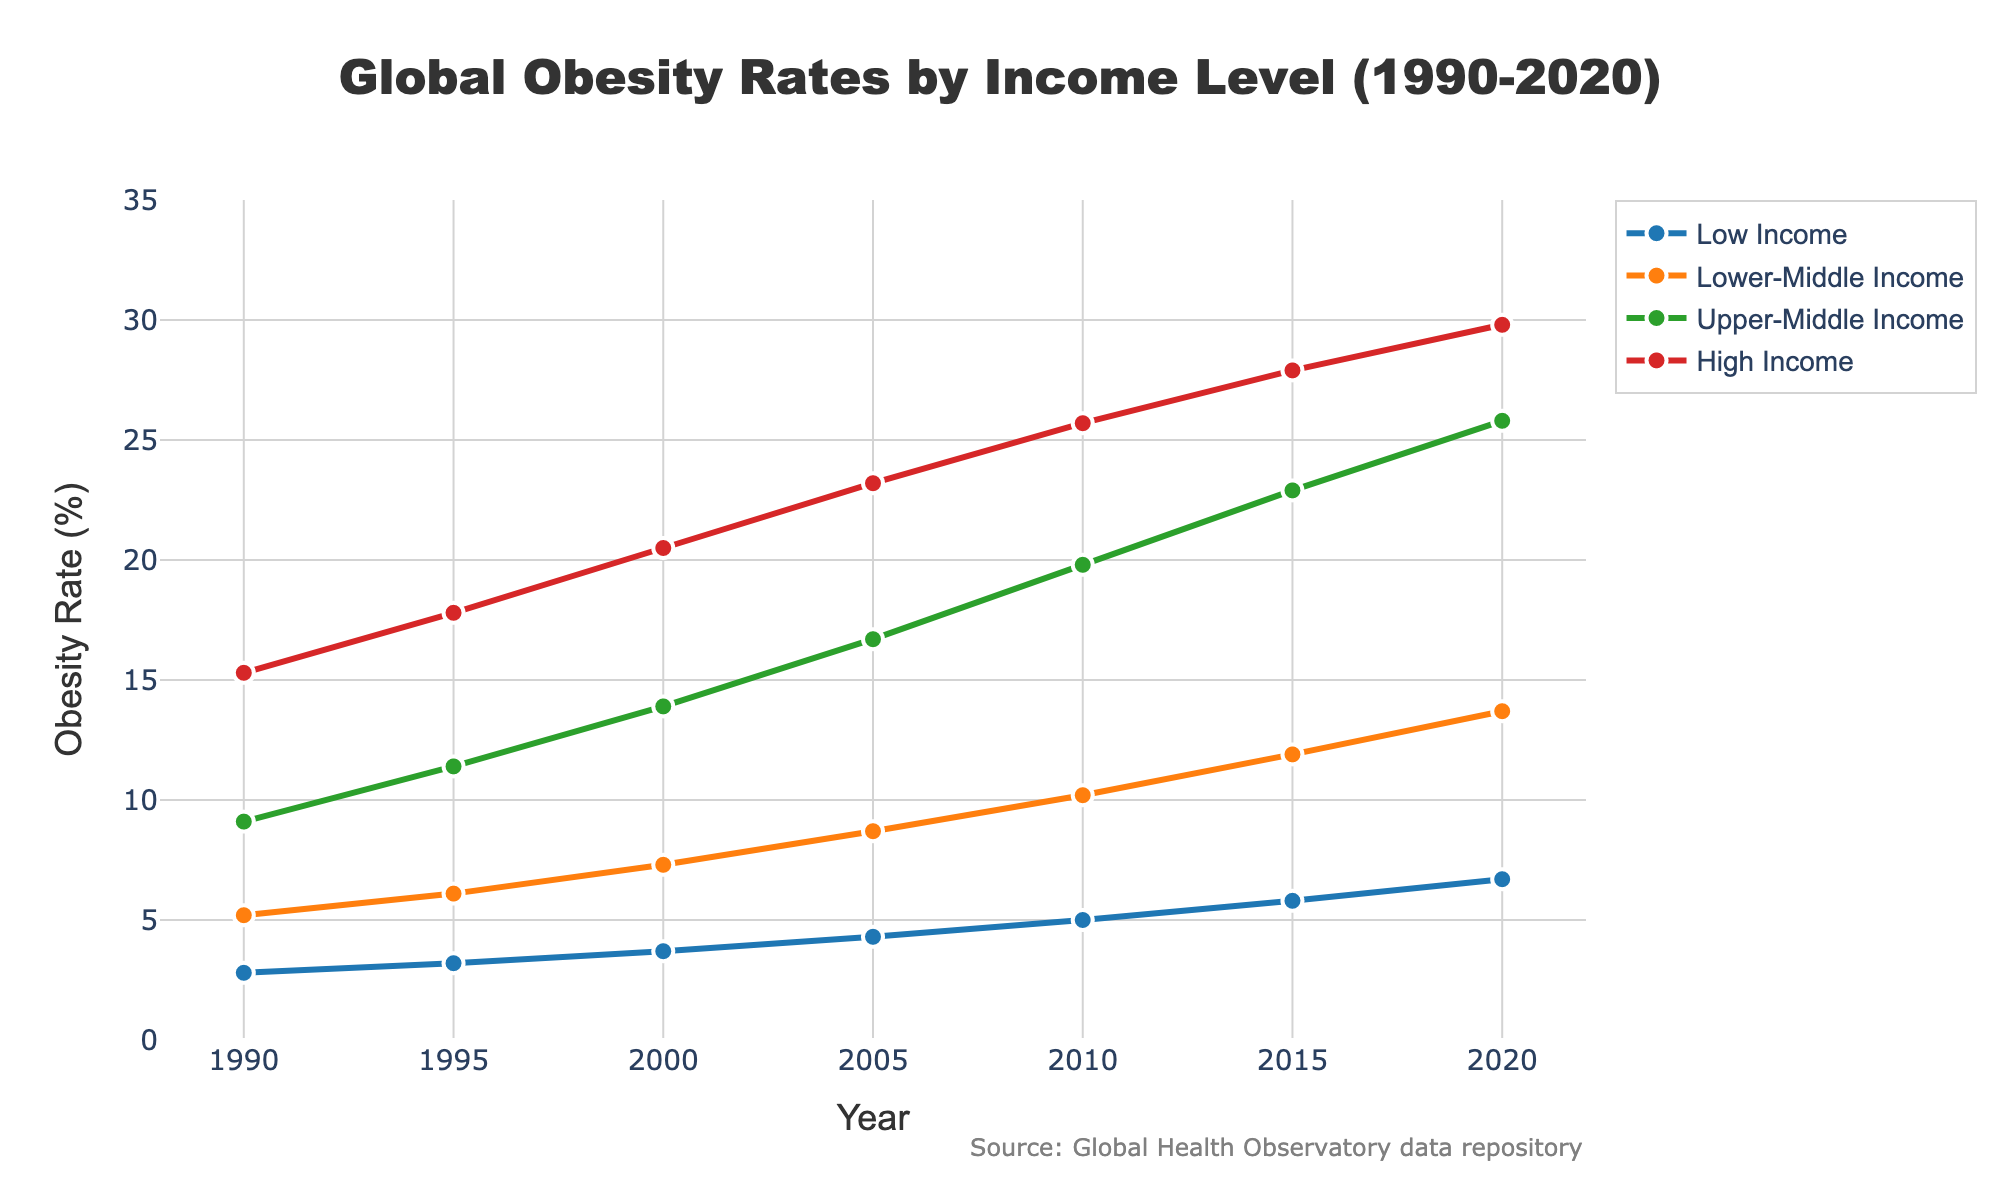What is the obesity rate for High Income countries in 2020? The obesity rate for High Income countries in 2020 can be directly read from the chart at the last data point on the "High Income" line.
Answer: 29.8% Which income level had the largest increase in obesity rates between 1990 and 2020? To determine the largest increase, subtract the 1990 value from the 2020 value for each income level: High Income: 29.8 - 15.3 = 14.5, Upper-Middle Income: 25.8 - 9.1 = 16.7, Lower-Middle Income: 13.7 - 5.2 = 8.5, Low Income: 6.7 - 2.8 = 3.9. Upper-Middle Income had the largest increase.
Answer: Upper-Middle Income In which year did the obesity rate for Lower-Middle Income countries first exceed 10%? Check when the plotted values for Lower-Middle Income countries surpass 10% by looking at the corresponding Y-axis value. It first happens in 2010.
Answer: 2010 By how many percentage points did the obesity rate of Low Income countries change from 1990 to 2000? Subtract the 1990 value from the 2000 value for Low Income countries: 3.7 - 2.8 = 0.9.
Answer: 0.9 What’s the average obesity rate for Upper-Middle Income countries over the provided years? The average can be calculated by summing the rates and dividing by the number of years: (9.1 + 11.4 + 13.9 + 16.7 + 19.8 + 22.9 + 25.8) / 7 = 16.37.
Answer: 16.37 Compare the obesity rates of High Income and Low Income countries in 1995. Which is higher, and by how much? Check the 1995 values for High Income (17.8) and Low Income (3.2), then subtract the smaller value from the larger value: 17.8 - 3.2 = 14.6. High Income is higher by 14.6 percentage points.
Answer: High Income by 14.6 If Upper-Middle Income countries continue to follow the same trend, what would you expect the obesity rate to be in 2025? Estimate the trend by observing the rate of increase. From 2015 to 2020, the rate increased by 25.8 - 22.9 = 2.9. Project this forward to 2025: 25.8 + 2.9 = 28.7.
Answer: 28.7 What trend do you observe in the obesity rates for High Income countries over the years? The trend is consistently upward, as the rate increases each recorded year.
Answer: Consistently upward Which income level had the smallest increase in obesity rates from 2000 to 2010? Calculate the increase for each level between these years. Low Income: 5.0 - 3.7 = 1.3, Lower-Middle Income: 10.2 - 7.3 = 2.9, Upper-Middle Income: 19.8 - 13.9 = 5.9, High Income: 25.7 - 20.5 = 5.2. Low Income had the smallest increase.
Answer: Low Income Between 2015 and 2020, which income level experienced the greatest change in obesity rates? Calculate the difference for each income level: High Income: 29.8 - 27.9 = 1.9, Upper-Middle Income: 25.8 - 22.9 = 2.9, Lower-Middle Income: 13.7 - 11.9 = 1.8, Low Income: 6.7 - 5.8 = 0.9. Upper-Middle Income has the greatest change.
Answer: Upper-Middle Income 